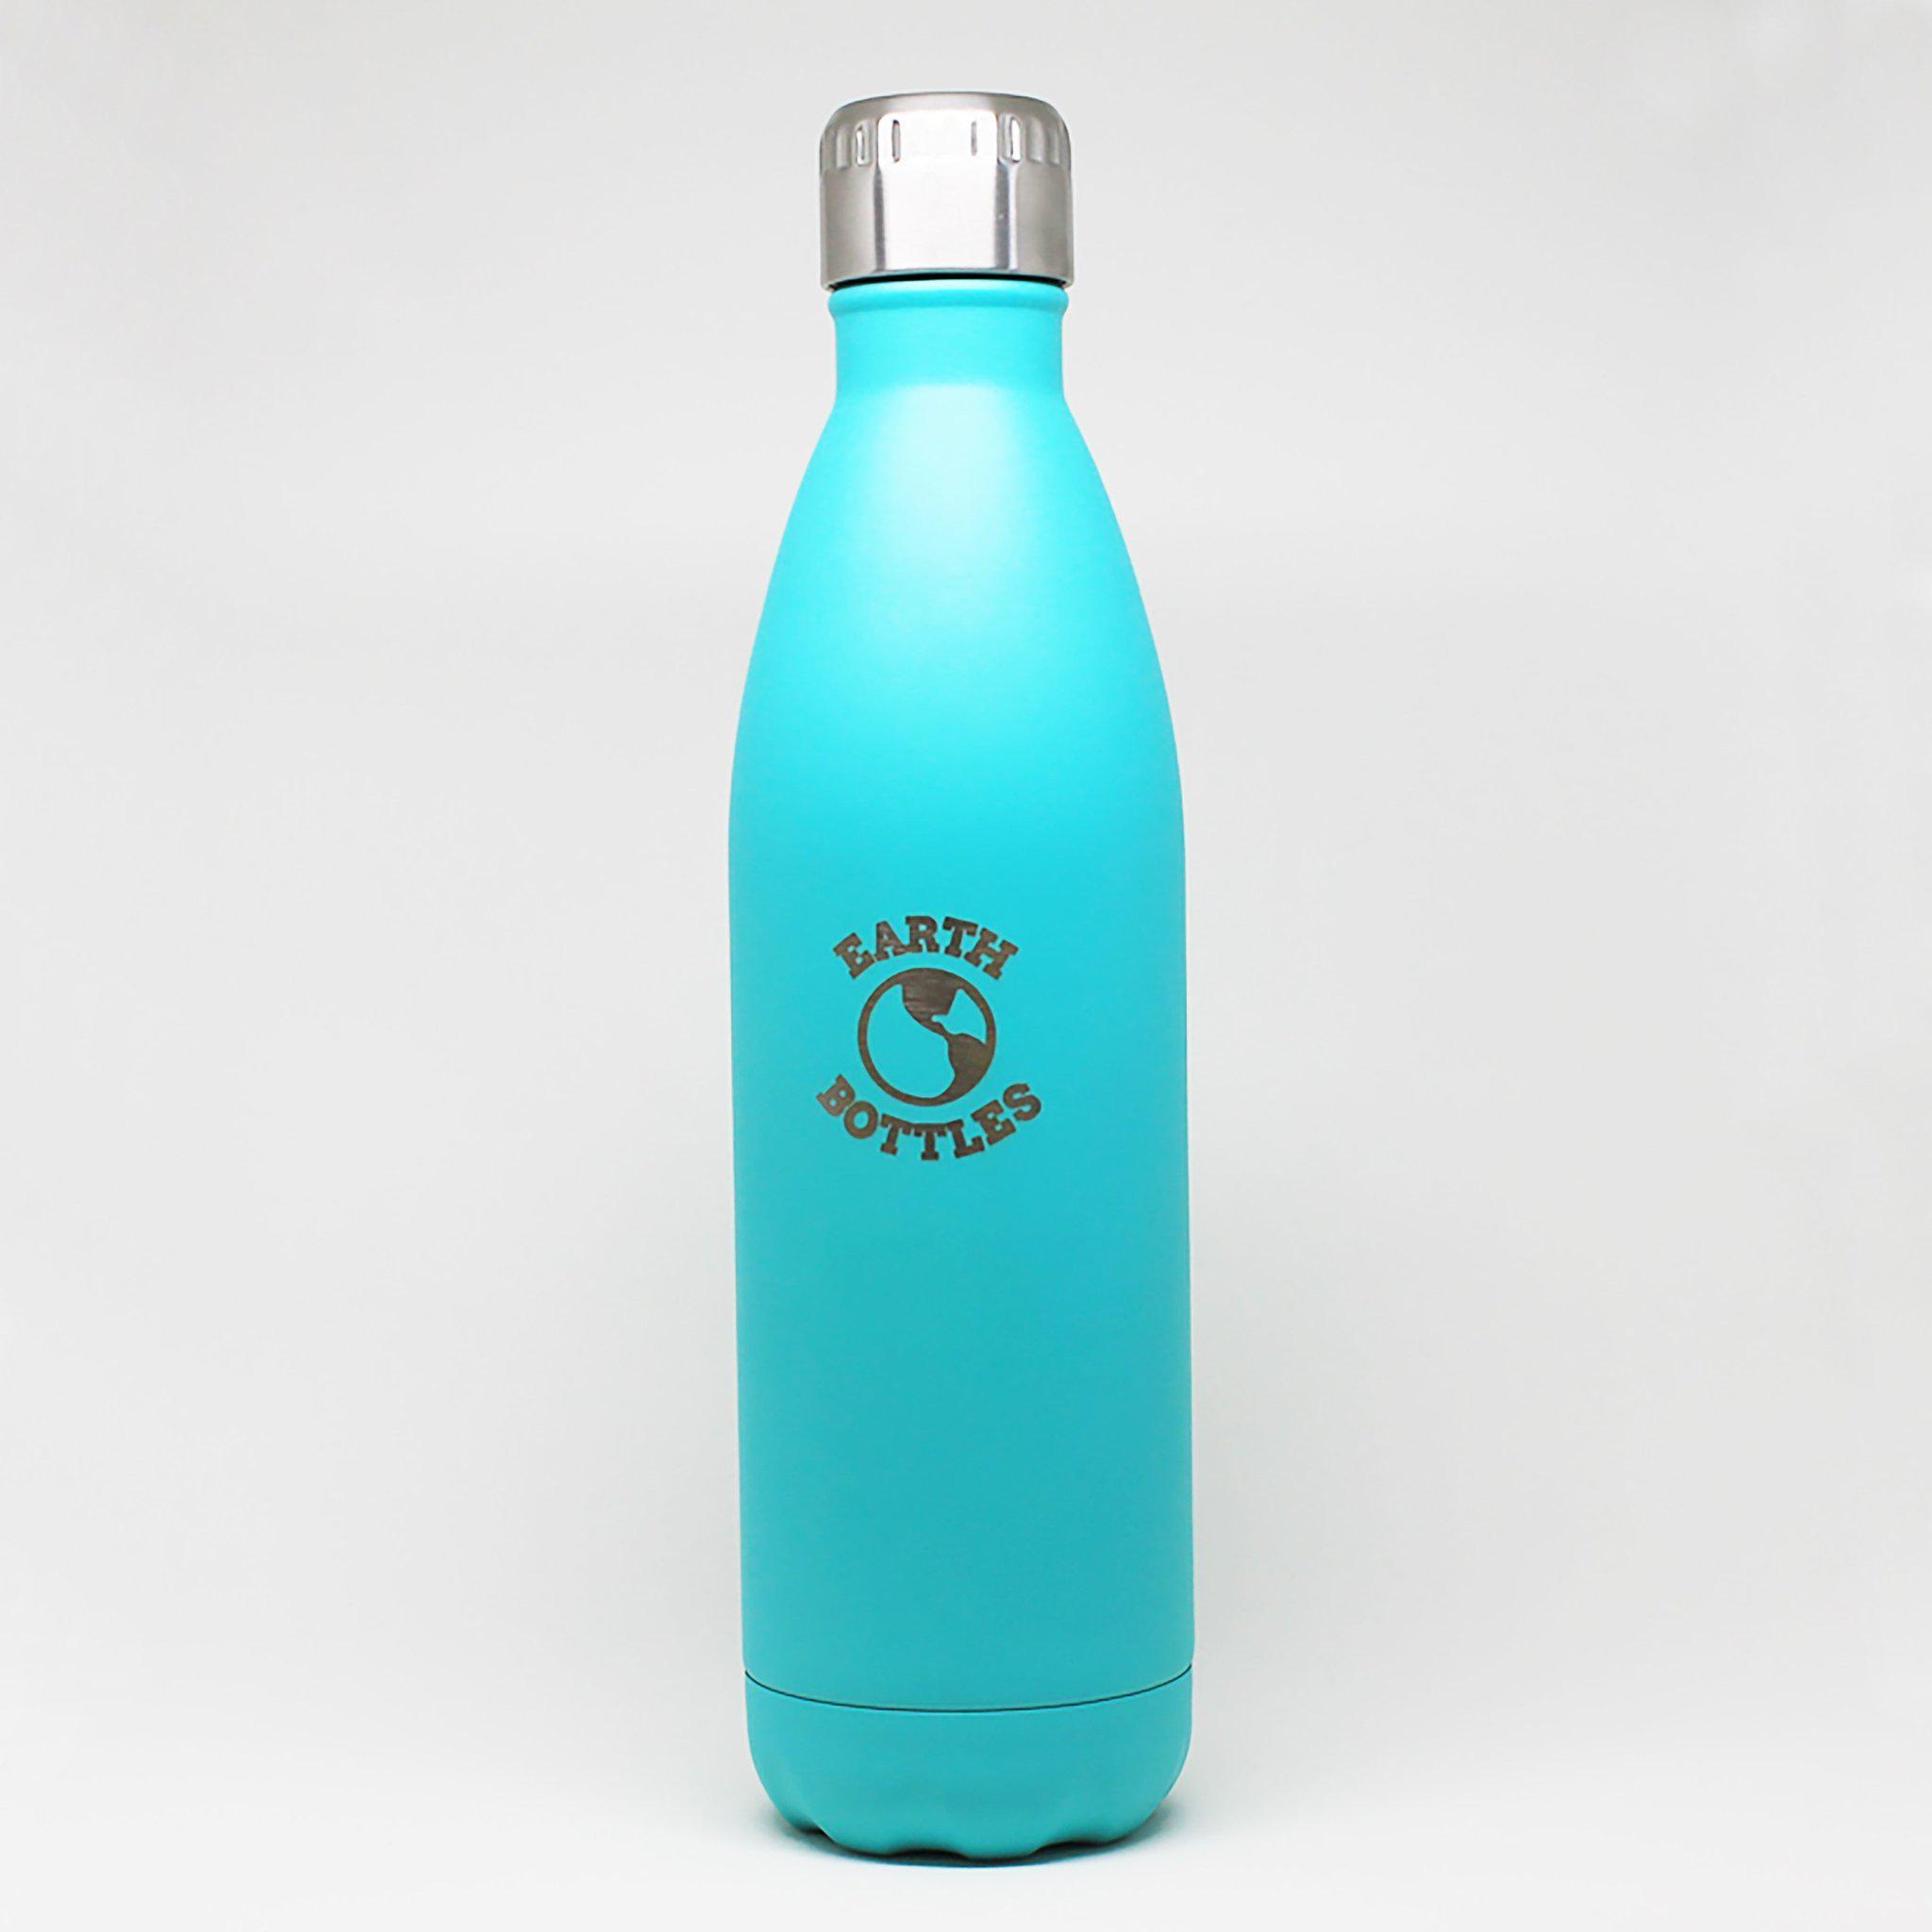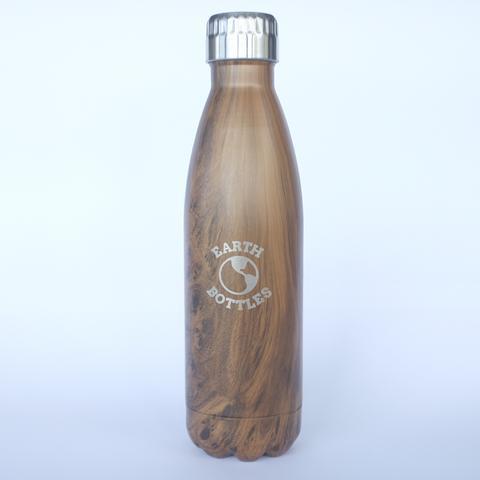The first image is the image on the left, the second image is the image on the right. Evaluate the accuracy of this statement regarding the images: "One image shows at least one teal colored stainless steel water bottle with a silver chrome cap". Is it true? Answer yes or no. Yes. The first image is the image on the left, the second image is the image on the right. Assess this claim about the two images: "An image shows at least one opaque robin's-egg blue water bottle with a silver cap on it.". Correct or not? Answer yes or no. Yes. 